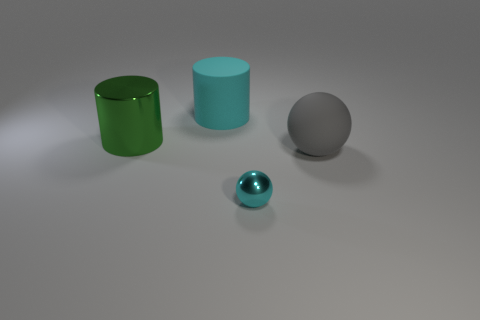Subtract 1 cylinders. How many cylinders are left? 1 Add 4 cyan matte cylinders. How many cyan matte cylinders exist? 5 Add 4 tiny metal things. How many objects exist? 8 Subtract 0 blue cylinders. How many objects are left? 4 Subtract all purple cylinders. Subtract all cyan cubes. How many cylinders are left? 2 Subtract all green cylinders. How many green spheres are left? 0 Subtract all small cyan balls. Subtract all big rubber objects. How many objects are left? 1 Add 1 small objects. How many small objects are left? 2 